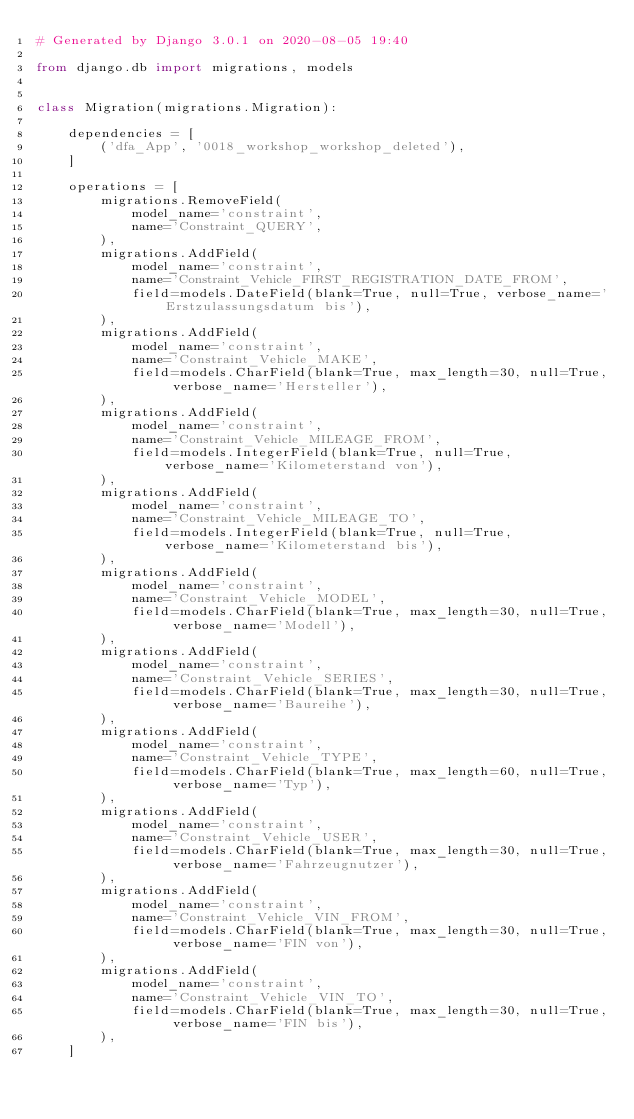Convert code to text. <code><loc_0><loc_0><loc_500><loc_500><_Python_># Generated by Django 3.0.1 on 2020-08-05 19:40

from django.db import migrations, models


class Migration(migrations.Migration):

    dependencies = [
        ('dfa_App', '0018_workshop_workshop_deleted'),
    ]

    operations = [
        migrations.RemoveField(
            model_name='constraint',
            name='Constraint_QUERY',
        ),
        migrations.AddField(
            model_name='constraint',
            name='Constraint_Vehicle_FIRST_REGISTRATION_DATE_FROM',
            field=models.DateField(blank=True, null=True, verbose_name='Erstzulassungsdatum bis'),
        ),
        migrations.AddField(
            model_name='constraint',
            name='Constraint_Vehicle_MAKE',
            field=models.CharField(blank=True, max_length=30, null=True, verbose_name='Hersteller'),
        ),
        migrations.AddField(
            model_name='constraint',
            name='Constraint_Vehicle_MILEAGE_FROM',
            field=models.IntegerField(blank=True, null=True, verbose_name='Kilometerstand von'),
        ),
        migrations.AddField(
            model_name='constraint',
            name='Constraint_Vehicle_MILEAGE_TO',
            field=models.IntegerField(blank=True, null=True, verbose_name='Kilometerstand bis'),
        ),
        migrations.AddField(
            model_name='constraint',
            name='Constraint_Vehicle_MODEL',
            field=models.CharField(blank=True, max_length=30, null=True, verbose_name='Modell'),
        ),
        migrations.AddField(
            model_name='constraint',
            name='Constraint_Vehicle_SERIES',
            field=models.CharField(blank=True, max_length=30, null=True, verbose_name='Baureihe'),
        ),
        migrations.AddField(
            model_name='constraint',
            name='Constraint_Vehicle_TYPE',
            field=models.CharField(blank=True, max_length=60, null=True, verbose_name='Typ'),
        ),
        migrations.AddField(
            model_name='constraint',
            name='Constraint_Vehicle_USER',
            field=models.CharField(blank=True, max_length=30, null=True, verbose_name='Fahrzeugnutzer'),
        ),
        migrations.AddField(
            model_name='constraint',
            name='Constraint_Vehicle_VIN_FROM',
            field=models.CharField(blank=True, max_length=30, null=True, verbose_name='FIN von'),
        ),
        migrations.AddField(
            model_name='constraint',
            name='Constraint_Vehicle_VIN_TO',
            field=models.CharField(blank=True, max_length=30, null=True, verbose_name='FIN bis'),
        ),
    ]
</code> 